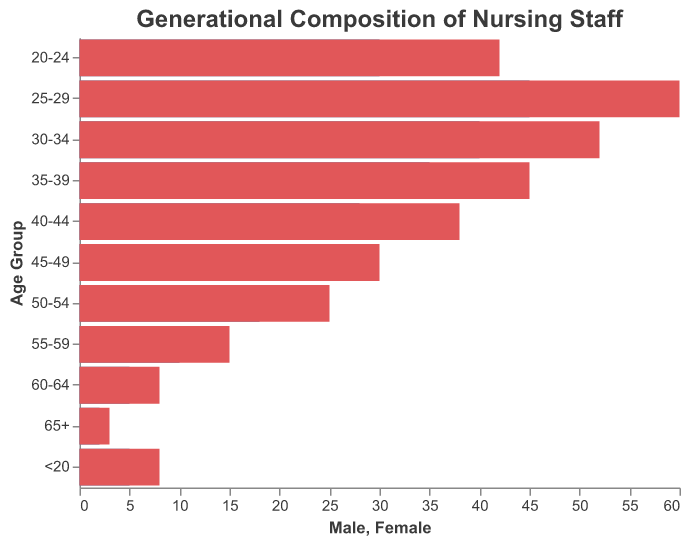What's the title of the figure? The title of the figure is displayed at the top. It reads "Generational Composition of Nursing Staff" in a font size of 16 and Arial font.
Answer: Generational Composition of Nursing Staff How many age groups are shown in the figure? By looking at the y-axis, we see it lists different age groups. Counting these age groups gives us 11 distinct groups.
Answer: 11 Which age group has the highest number of female staff? We look for the longest bar on the female side, which corresponds to the 25-29 age group with a value of 60.
Answer: 25-29 In the 35-39 age group, how many more female staff are there compared to male staff? For the 35-39 age group, the female count is 45 and the male count is 35. To find the difference, we calculate 45 - 35 = 10.
Answer: 10 Which gender has more employees in the 60-64 age group? By comparing the bar lengths for the 60-64 age group, the male bar represents -5 and the female bar represents 8. The female bar is longer, indicating more female staff.
Answer: Female What's the gender ratio (female to male) in the 20-24 age group? In the 20-24 age group, there are 42 females and 30 males. The ratio of females to males is calculated as 42/30 = 1.4.
Answer: 1.4 What is the total number of male staff across all age groups? We sum up all the male values: (-2) + (-5) + (-10) + (-18) + (-22) + (-28) + (-35) + (-40) + (-45) + (-30) + (-5). The total is -240 (but noted as 240 individuals).
Answer: 240 Which age group has the closest number of male and female staff? We look for age groups where the difference between male and female counts is smallest. The age group <20 has a difference of 3 (5 male, 8 female).
Answer: <20 Is there any age group with equal male and female staff? We examine each age group, none have equal counts for both genders.
Answer: No In which age group is the smallest male staff count? Among all age groups, the smallest male count is in the 65+ age group, which is -2.
Answer: 65+ 